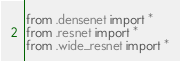<code> <loc_0><loc_0><loc_500><loc_500><_Python_>from .densenet import *
from .resnet import *
from .wide_resnet import *
</code> 